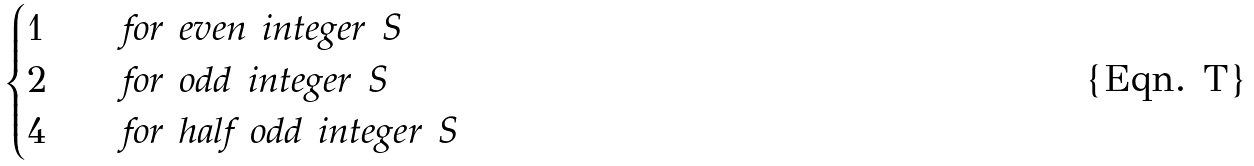<formula> <loc_0><loc_0><loc_500><loc_500>\begin{cases} 1 & \quad \text {for even integer } S \\ 2 & \quad \text {for odd integer } S \\ 4 & \quad \text {for half odd integer } S \end{cases}</formula> 